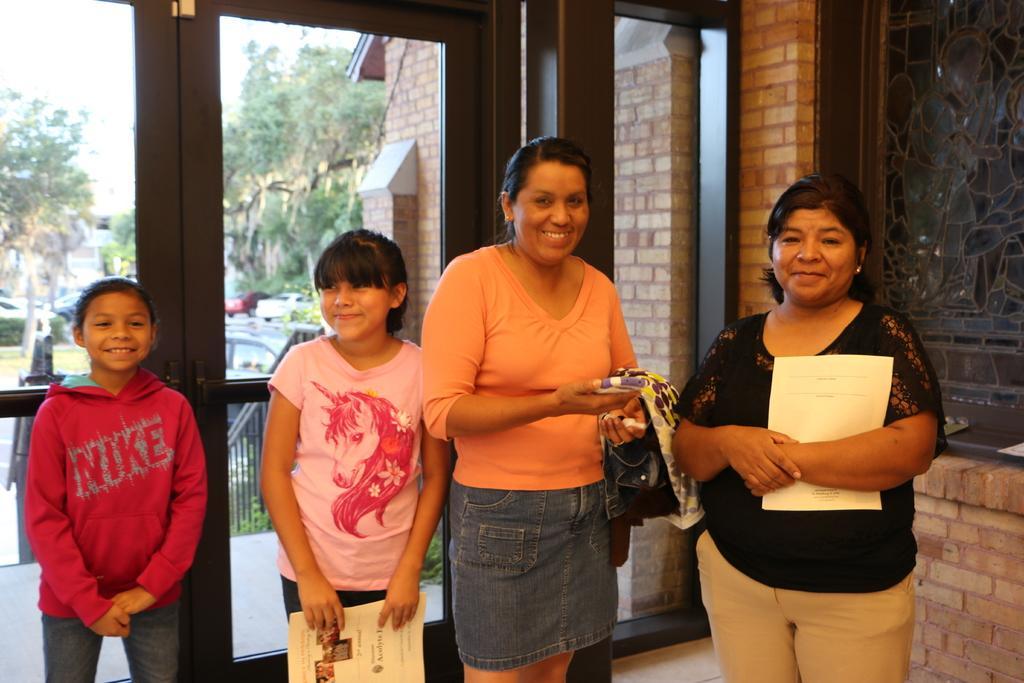Can you describe this image briefly? In this image we can see two women and two girls are standing. One woman is wearing black top. And the other woman is wearing orange top with skirt and holding mobile in her hand. One girl is wearing pink t-shirt and holding paper in her hand and the other girl is wearing dark pink color hoodie. Behind door is there and behind the door trees are present. 